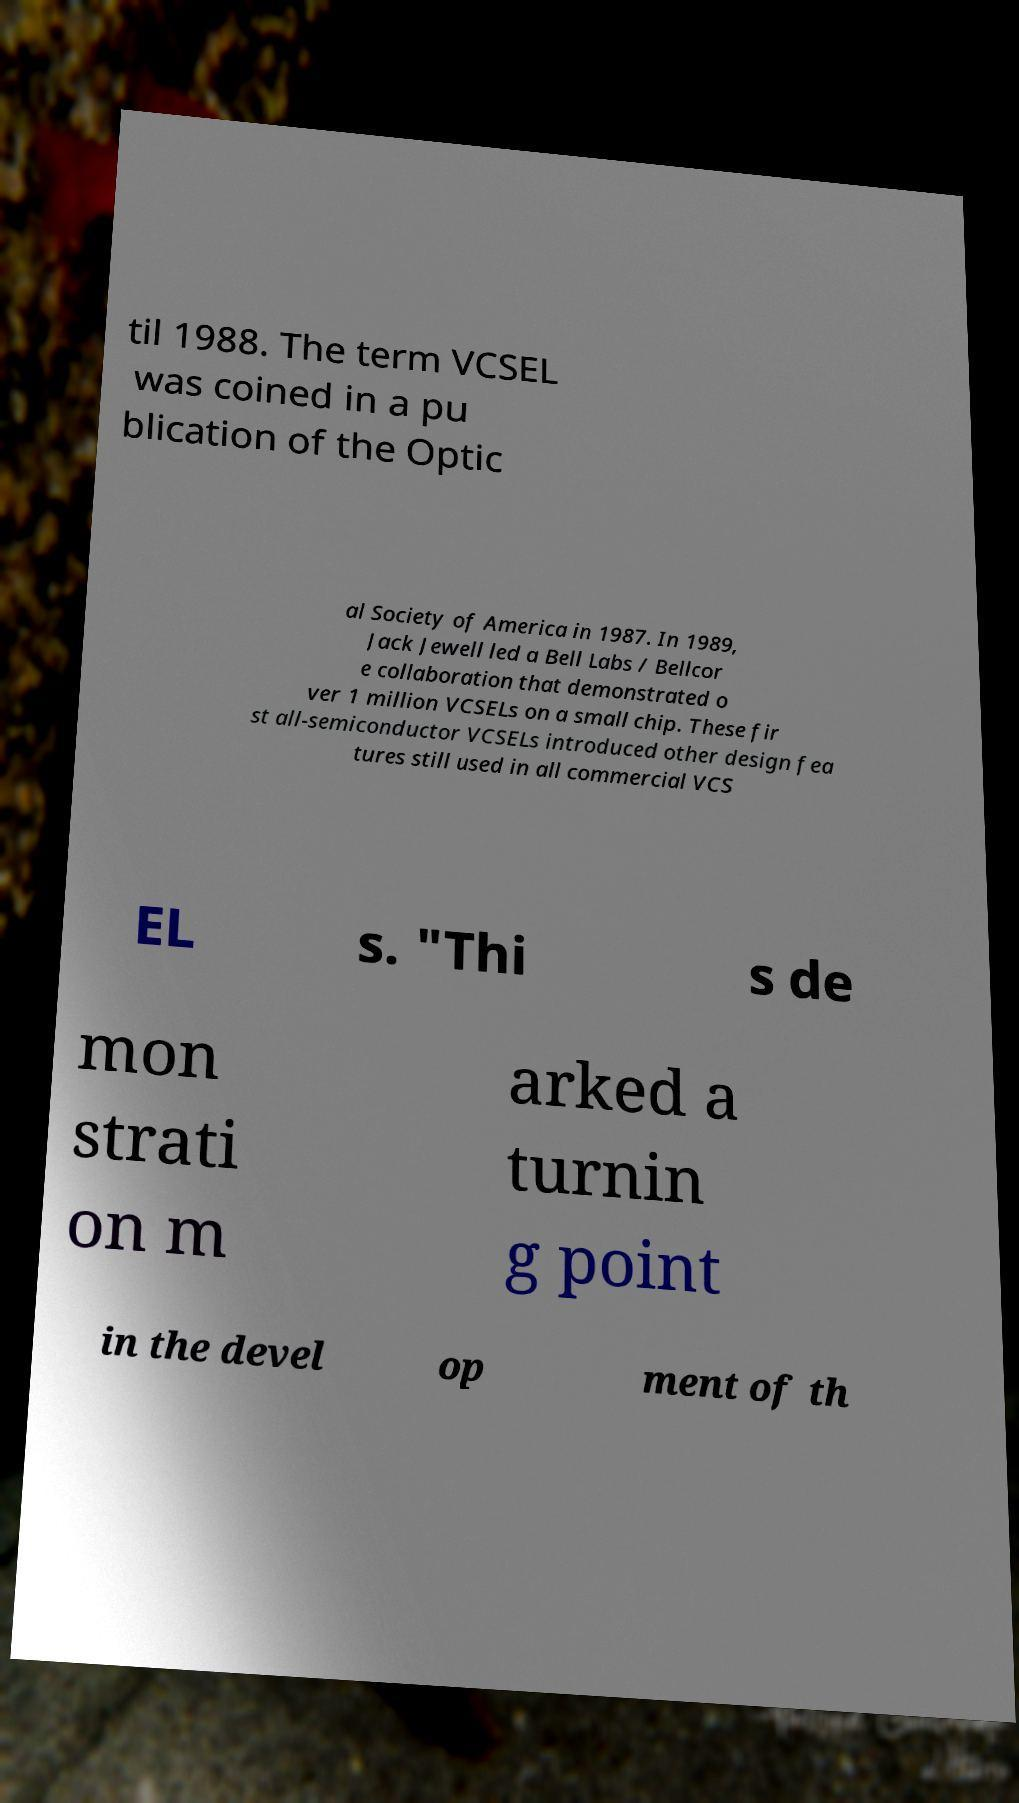Can you read and provide the text displayed in the image?This photo seems to have some interesting text. Can you extract and type it out for me? til 1988. The term VCSEL was coined in a pu blication of the Optic al Society of America in 1987. In 1989, Jack Jewell led a Bell Labs / Bellcor e collaboration that demonstrated o ver 1 million VCSELs on a small chip. These fir st all-semiconductor VCSELs introduced other design fea tures still used in all commercial VCS EL s. "Thi s de mon strati on m arked a turnin g point in the devel op ment of th 